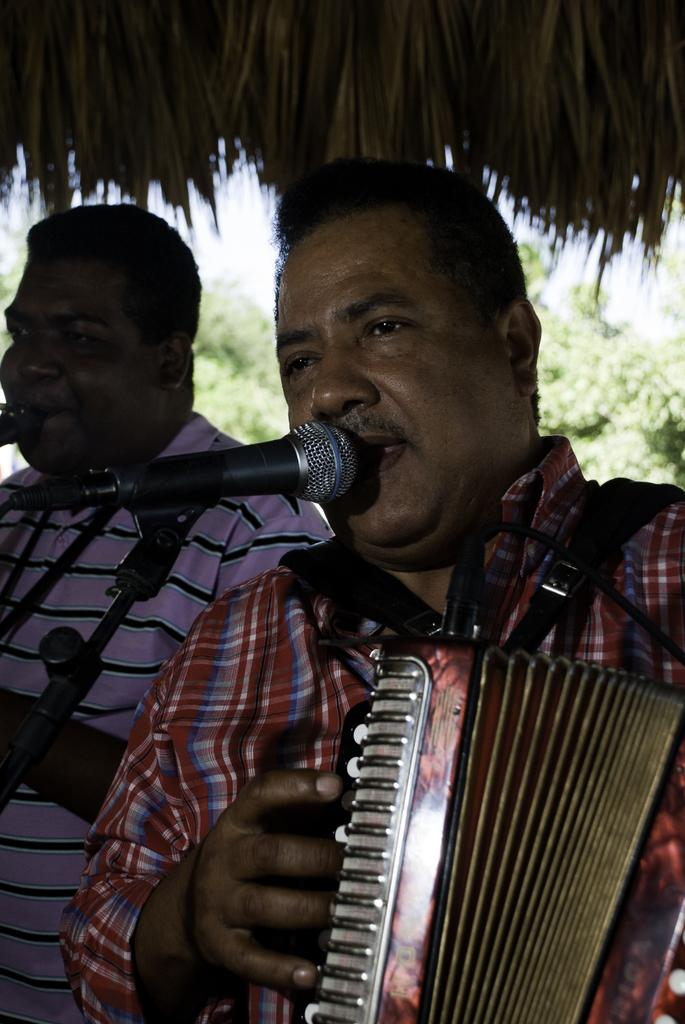How many people are present in the image? There are two people in the image. What is one of the people holding? One person is holding an accordion. What equipment is visible in the image for amplifying sound? There is a microphone with a microphone stand in the image. What can be seen in the background of the image? There are trees in the background of the image. What type of cheese is being used to control the pest problem in the image? There is no cheese or pest problem present in the image. 